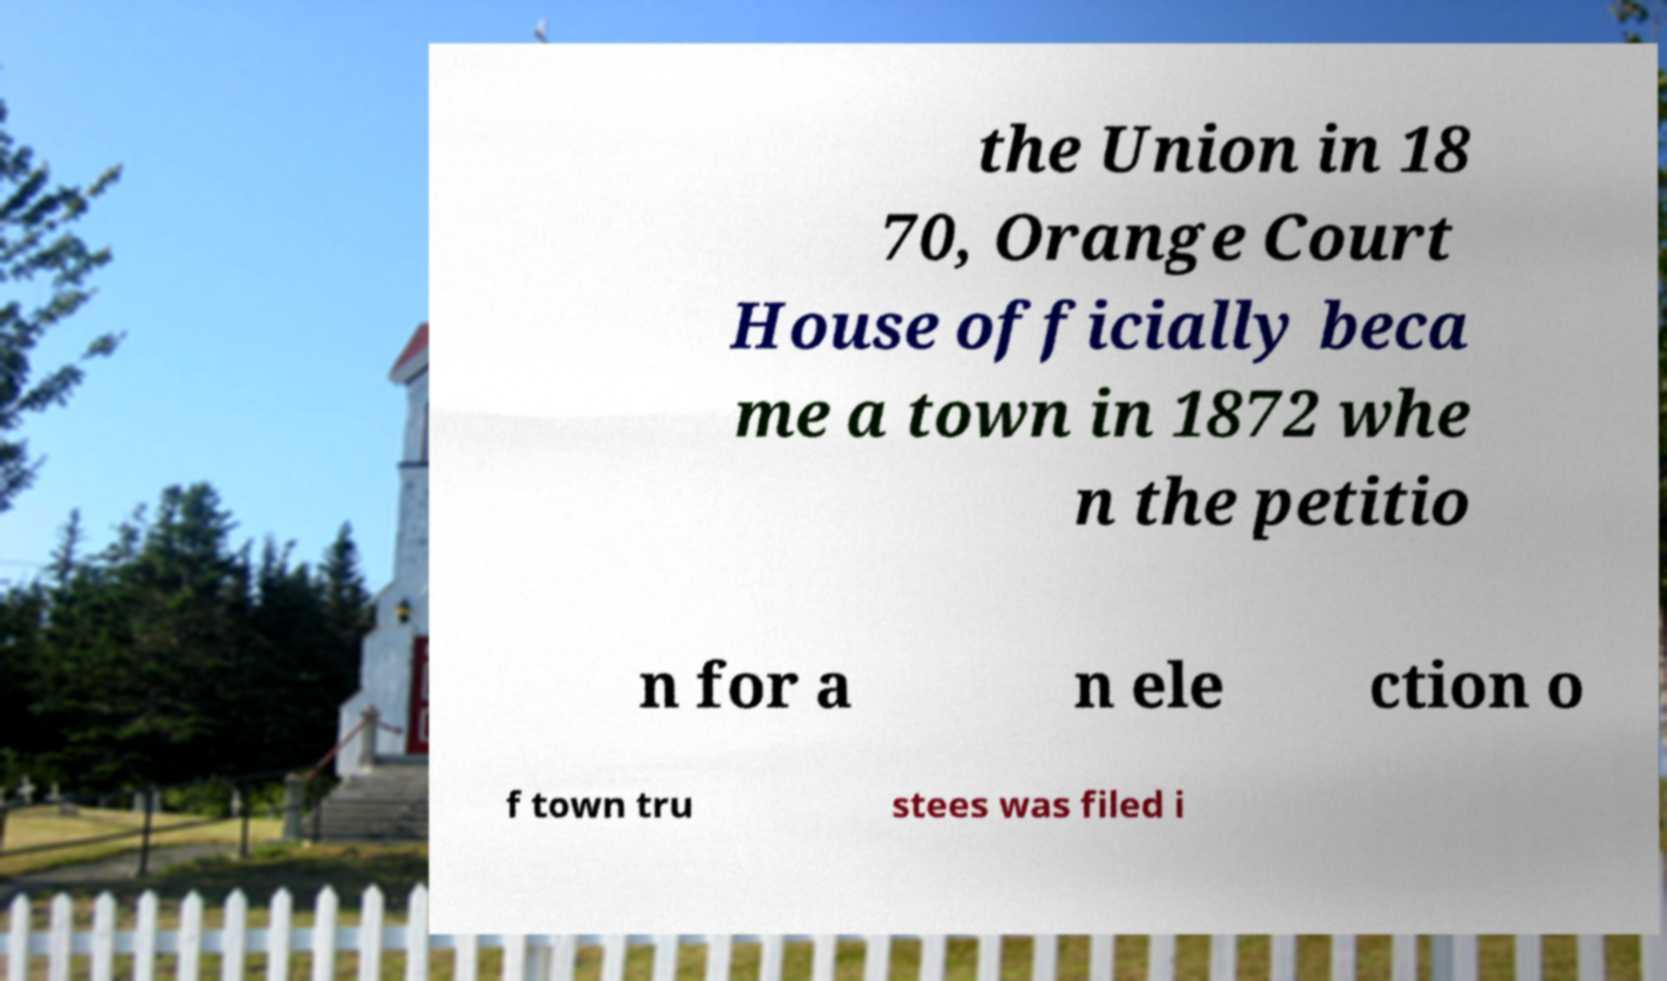Could you extract and type out the text from this image? the Union in 18 70, Orange Court House officially beca me a town in 1872 whe n the petitio n for a n ele ction o f town tru stees was filed i 